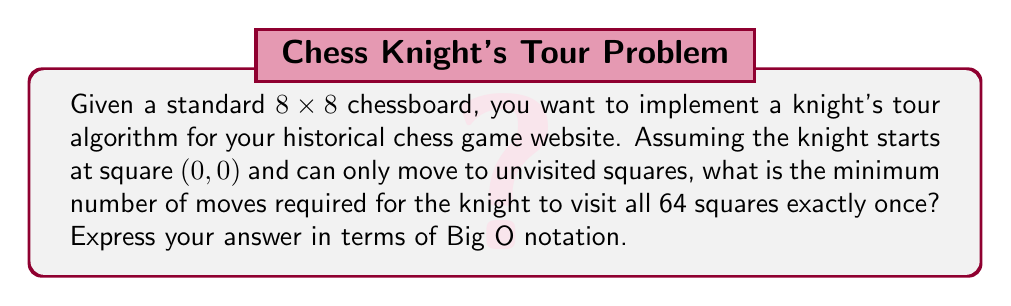Can you answer this question? To solve this problem, we need to consider the following:

1. The knight's tour is a graph traversal problem where each square on the chessboard represents a node, and each legal knight's move represents an edge.

2. Since we need to visit all squares exactly once, this is a Hamiltonian path problem.

3. The optimal solution for a knight's tour on an 8x8 chessboard always exists and requires visiting all 64 squares.

4. The best-known algorithms for solving the knight's tour problem use backtracking or Warnsdorff's rule.

5. Warnsdorff's rule is a heuristic that always chooses the next move with the fewest onward moves. This significantly reduces the search space.

6. Using Warnsdorff's rule, the time complexity can be approximated as follows:

   - At each step, we need to check up to 8 possible moves (worst case).
   - For each of these moves, we need to count the number of onward moves (up to 8 again).
   - We do this for all 64 squares on the board.

   So, the time complexity is approximately:

   $$O(64 \times 8 \times 8) = O(4096) = O(1)$$

7. However, this is a simplification. In the worst case, where Warnsdorff's rule doesn't lead directly to a solution, we might need to backtrack. The worst-case time complexity of backtracking for the knight's tour problem is:

   $$O(8^{N^2})$$

   where N is the board size (8 in this case).

8. But in practice, using Warnsdorff's rule, the average-case time complexity is much better and can be approximated as:

   $$O(N^2)$$

   where N is the board size.

Therefore, for an 8x8 chessboard, the minimum number of moves is always 63 (as we start on the first square), and the time complexity to find this optimal path using Warnsdorff's rule is approximately $O(N^2) = O(64) = O(1)$ in the average case, but $O(8^{64})$ in the worst case.
Answer: $O(N^2)$ or $O(1)$ for an 8x8 board in the average case, where N is the board size. 